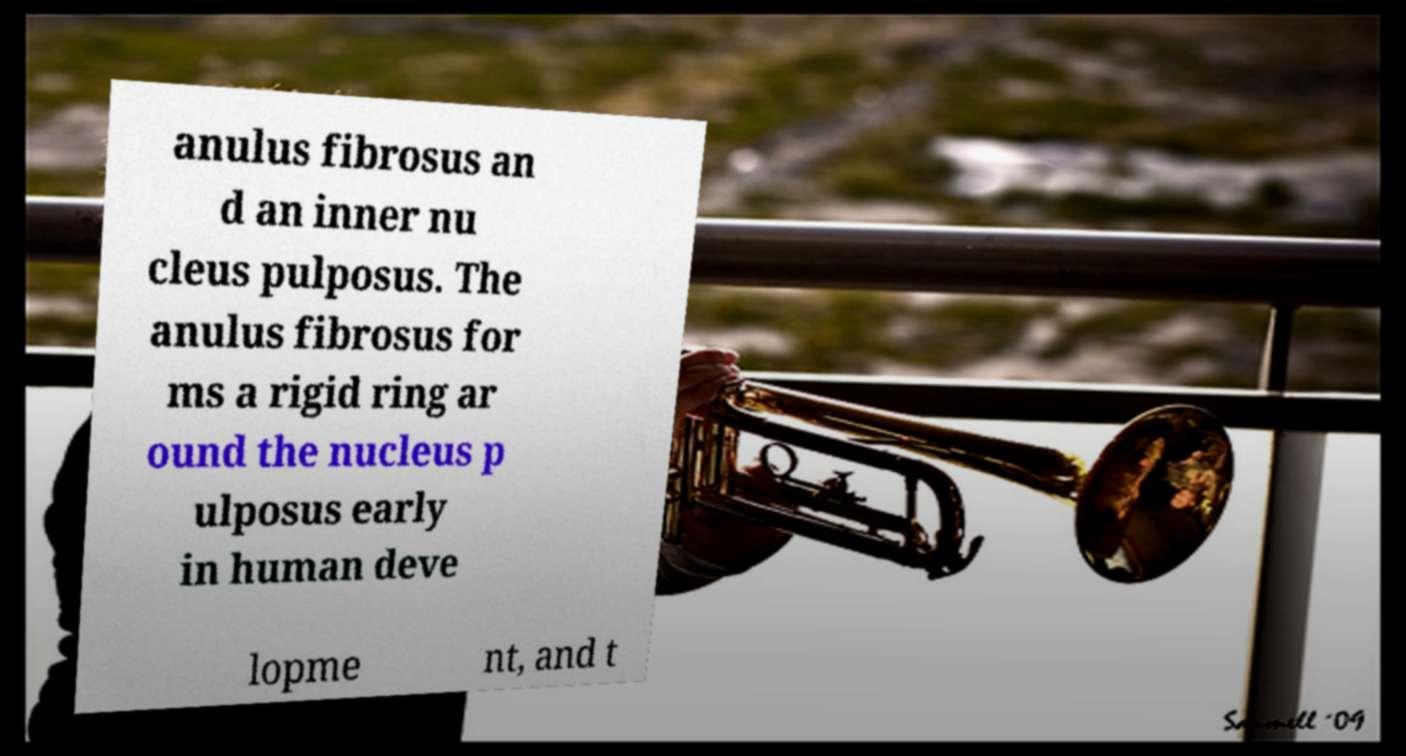What messages or text are displayed in this image? I need them in a readable, typed format. anulus fibrosus an d an inner nu cleus pulposus. The anulus fibrosus for ms a rigid ring ar ound the nucleus p ulposus early in human deve lopme nt, and t 